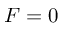<formula> <loc_0><loc_0><loc_500><loc_500>F = 0</formula> 